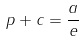Convert formula to latex. <formula><loc_0><loc_0><loc_500><loc_500>\ p + c = { \frac { a } { e } }</formula> 